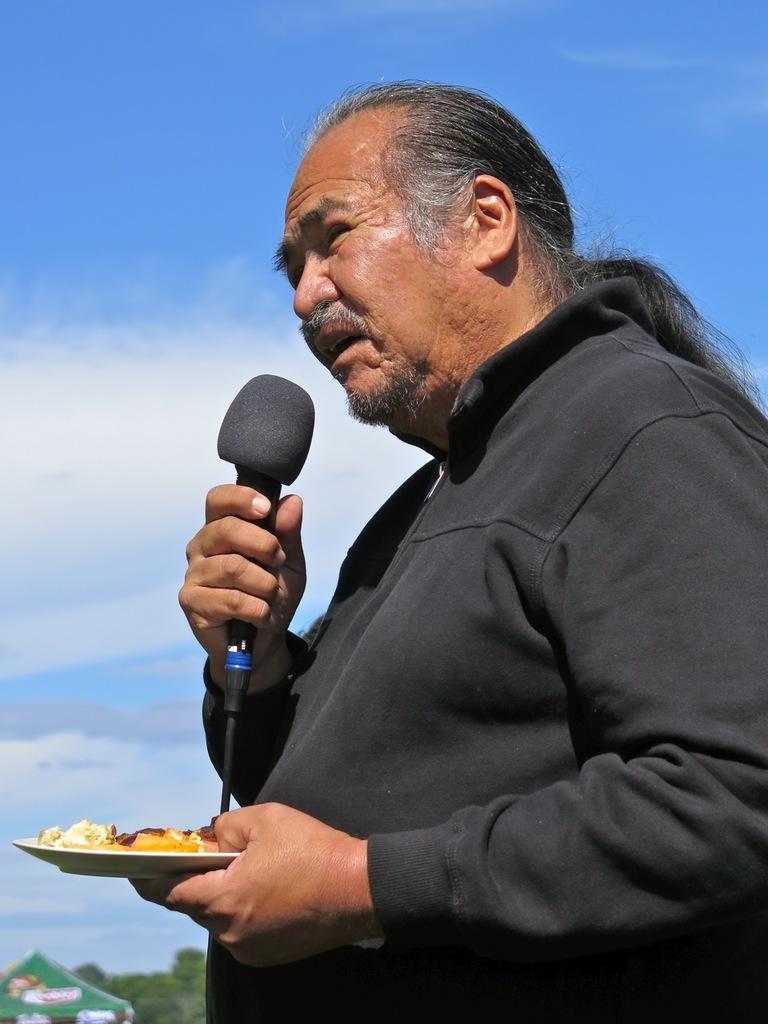In one or two sentences, can you explain what this image depicts? In this image I can see a man holding a mike in his right hand and a bowl with food in left hand. On the top of the image I can see the sky in blue color. 